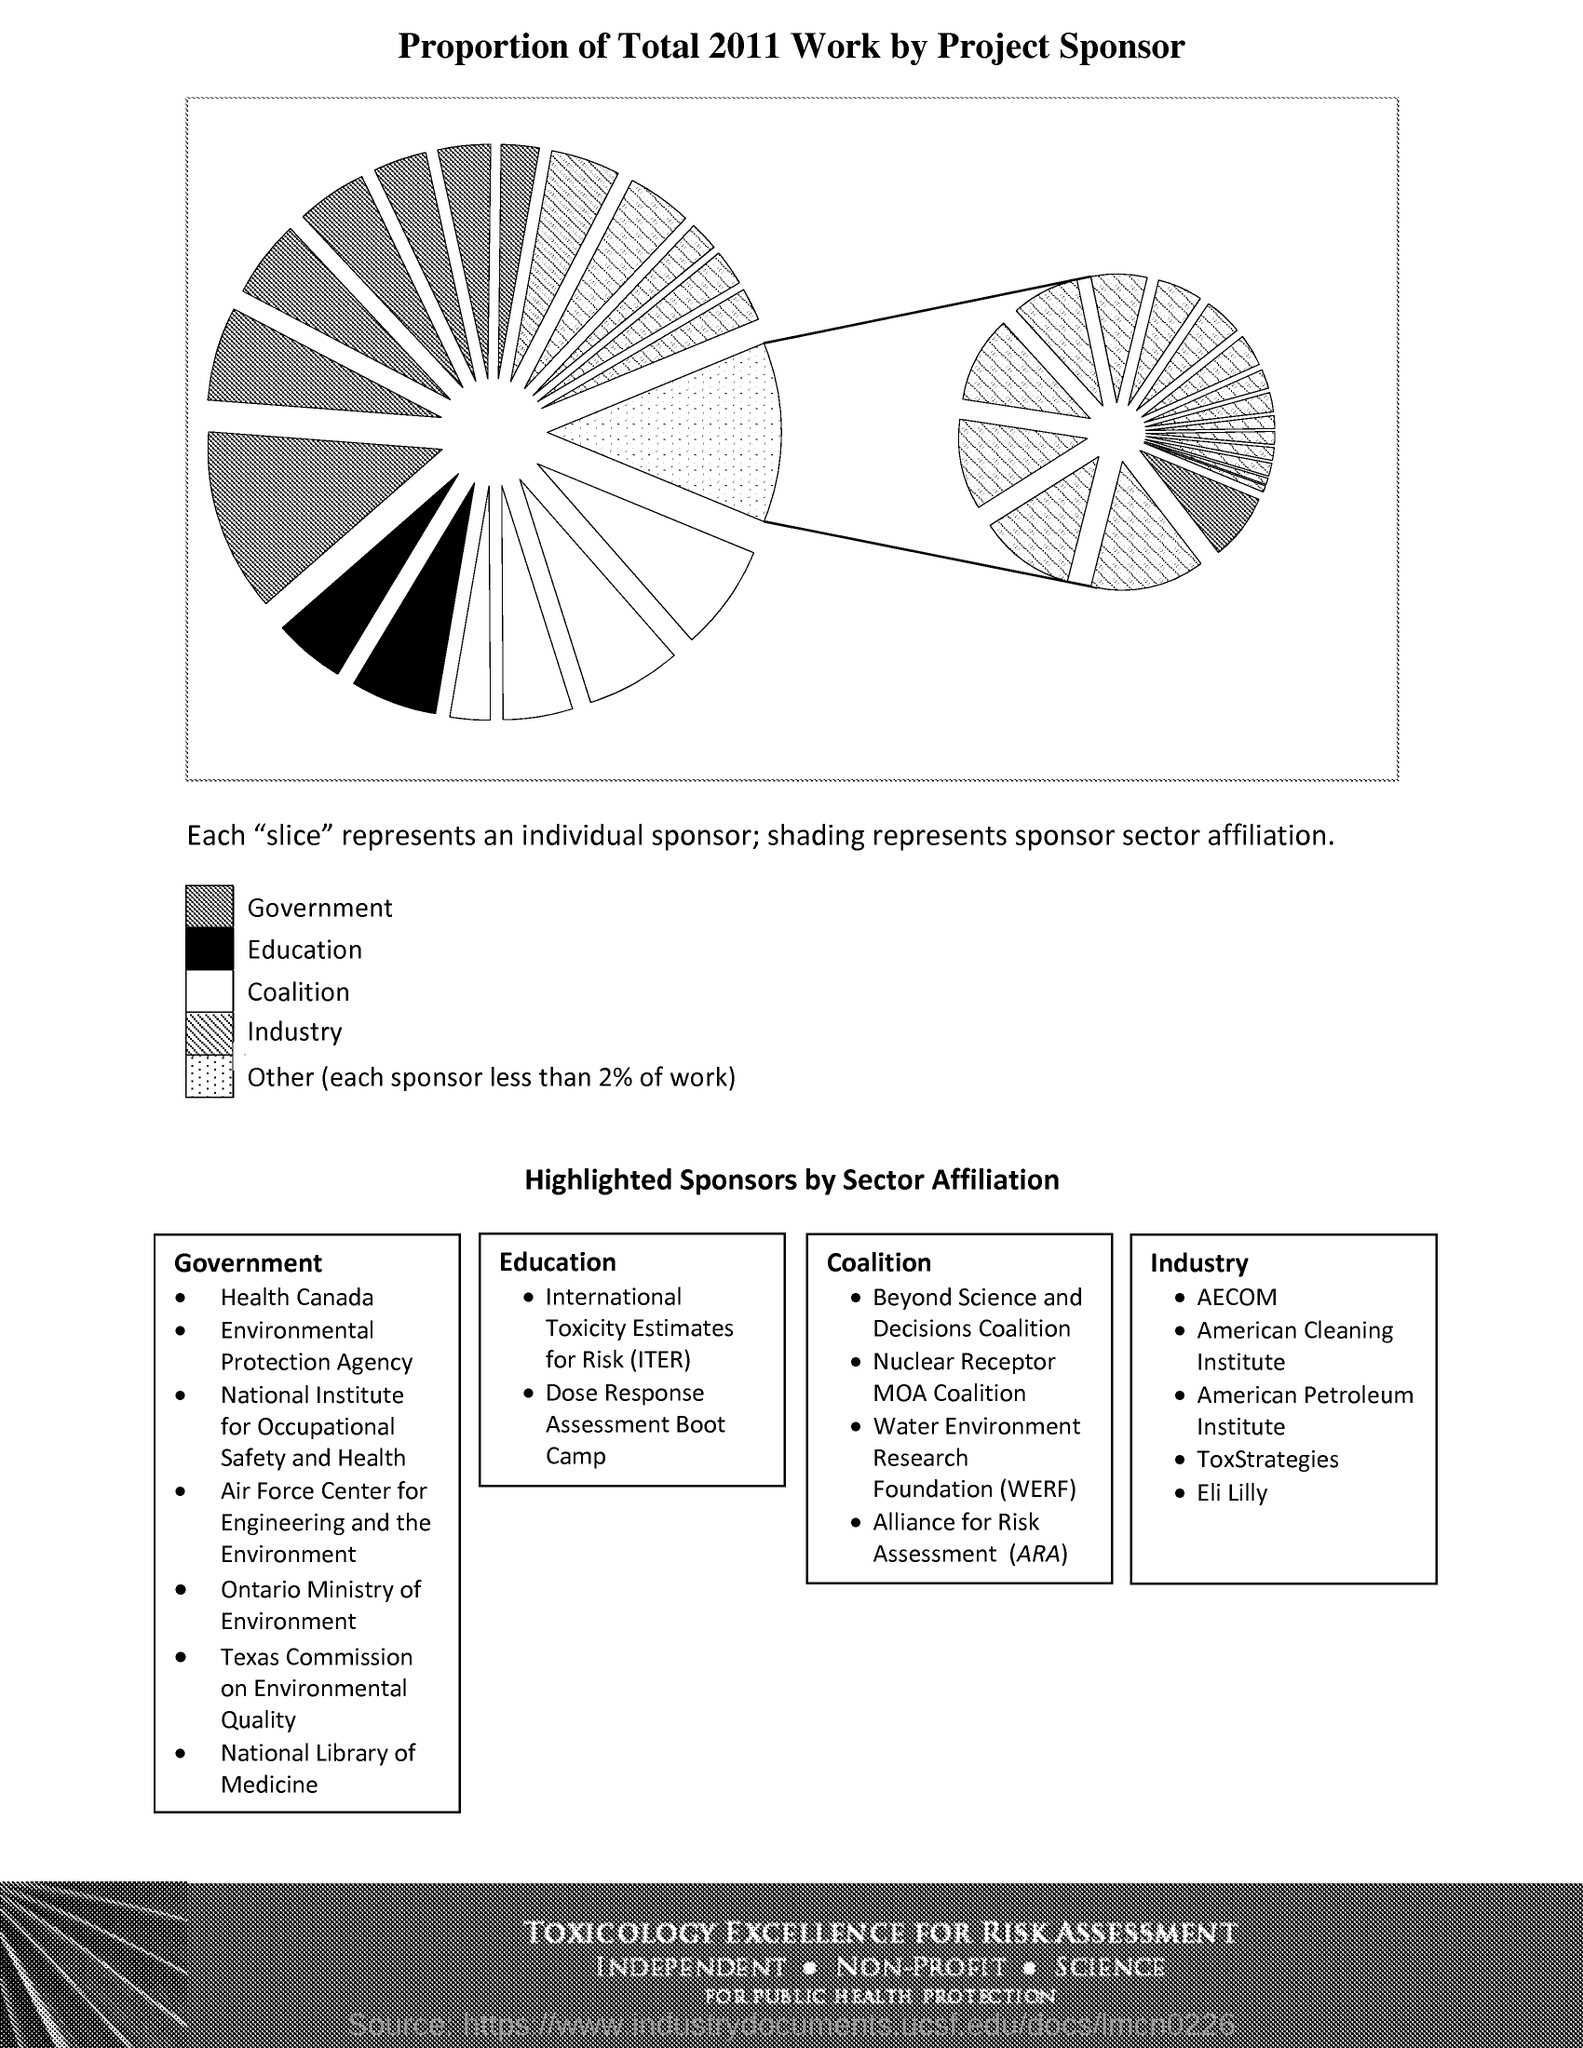Indicate a few pertinent items in this graphic. Each slice represents an individual sponsor, with their name and logo prominently displayed on the front of the slice. The shading represents the sponsor sector affiliation of a company. ARA stands for the Alliance for Risk Assessment. The Water Environment Research Foundation is an organization dedicated to advancing knowledge and promoting sustainable practices in the field of water resources management. 